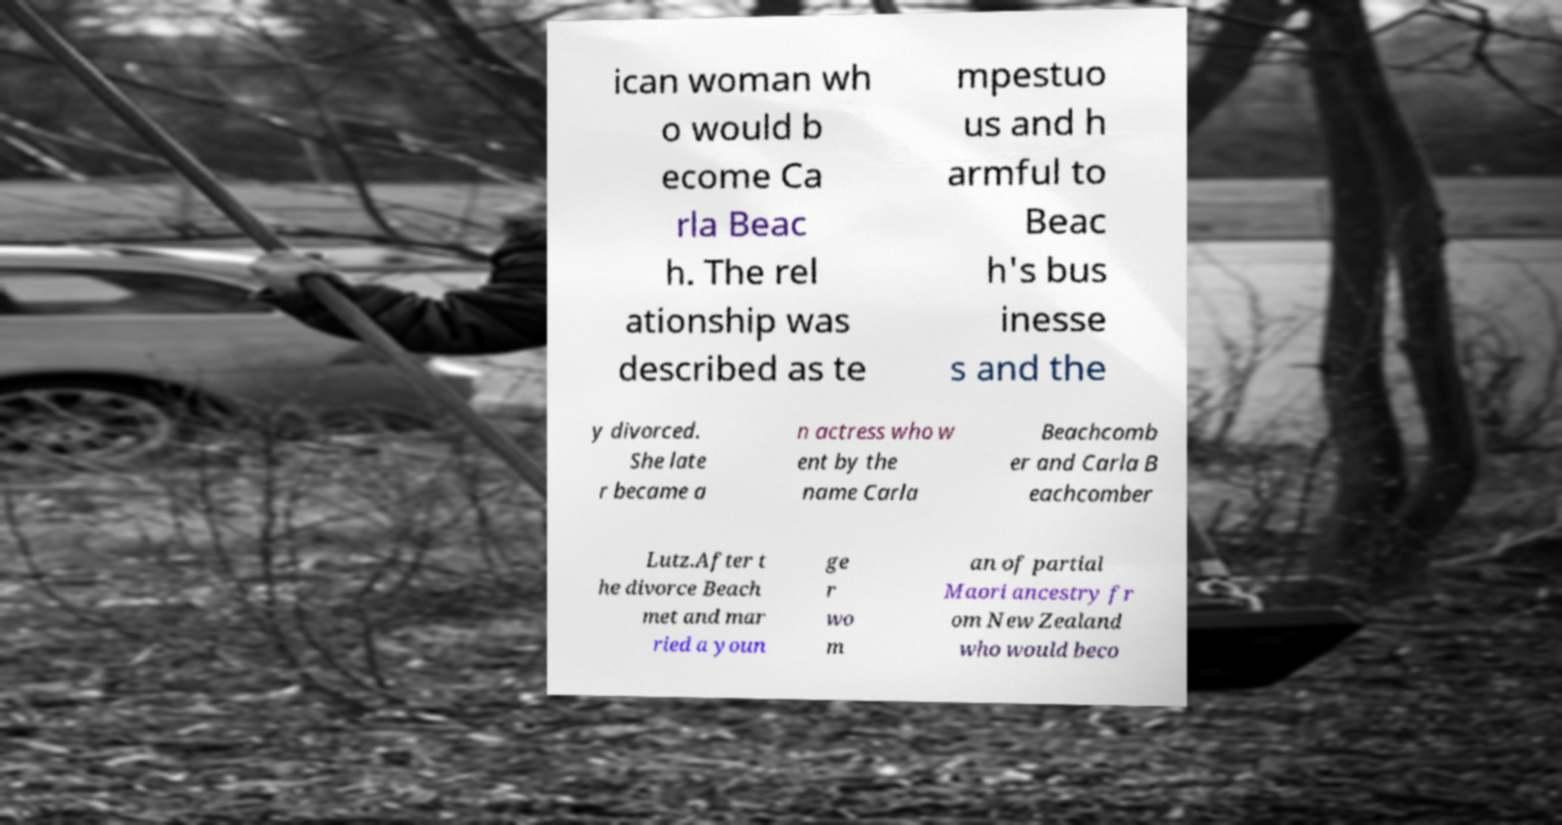For documentation purposes, I need the text within this image transcribed. Could you provide that? ican woman wh o would b ecome Ca rla Beac h. The rel ationship was described as te mpestuo us and h armful to Beac h's bus inesse s and the y divorced. She late r became a n actress who w ent by the name Carla Beachcomb er and Carla B eachcomber Lutz.After t he divorce Beach met and mar ried a youn ge r wo m an of partial Maori ancestry fr om New Zealand who would beco 